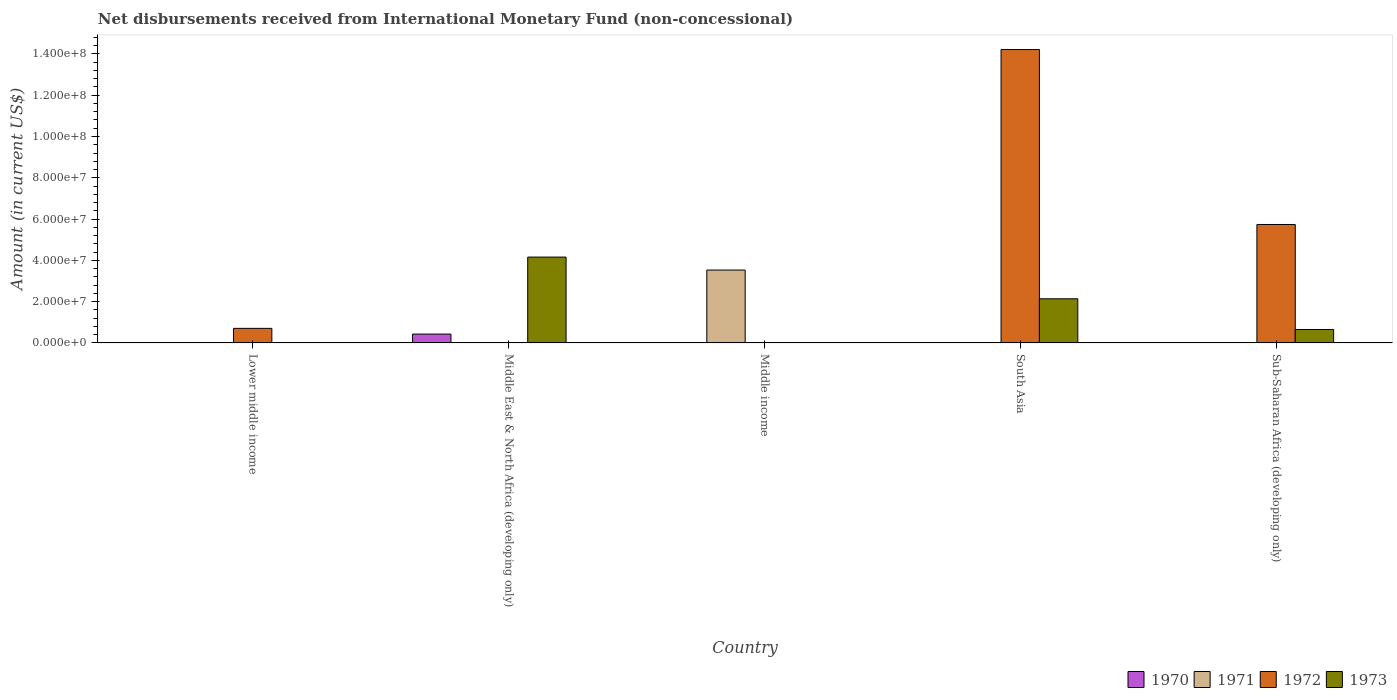How many different coloured bars are there?
Offer a terse response. 4. In how many cases, is the number of bars for a given country not equal to the number of legend labels?
Provide a short and direct response. 5. Across all countries, what is the maximum amount of disbursements received from International Monetary Fund in 1970?
Offer a very short reply. 4.30e+06. In which country was the amount of disbursements received from International Monetary Fund in 1970 maximum?
Offer a terse response. Middle East & North Africa (developing only). What is the total amount of disbursements received from International Monetary Fund in 1971 in the graph?
Give a very brief answer. 3.53e+07. What is the difference between the amount of disbursements received from International Monetary Fund in 1971 in Middle East & North Africa (developing only) and the amount of disbursements received from International Monetary Fund in 1973 in Lower middle income?
Your answer should be compact. 0. What is the average amount of disbursements received from International Monetary Fund in 1971 per country?
Your answer should be very brief. 7.06e+06. What is the difference between the amount of disbursements received from International Monetary Fund of/in 1973 and amount of disbursements received from International Monetary Fund of/in 1972 in Sub-Saharan Africa (developing only)?
Give a very brief answer. -5.09e+07. In how many countries, is the amount of disbursements received from International Monetary Fund in 1970 greater than 128000000 US$?
Offer a very short reply. 0. What is the difference between the highest and the second highest amount of disbursements received from International Monetary Fund in 1973?
Your answer should be compact. 3.51e+07. What is the difference between the highest and the lowest amount of disbursements received from International Monetary Fund in 1971?
Keep it short and to the point. 3.53e+07. In how many countries, is the amount of disbursements received from International Monetary Fund in 1973 greater than the average amount of disbursements received from International Monetary Fund in 1973 taken over all countries?
Keep it short and to the point. 2. How many countries are there in the graph?
Provide a short and direct response. 5. Are the values on the major ticks of Y-axis written in scientific E-notation?
Give a very brief answer. Yes. Does the graph contain any zero values?
Offer a very short reply. Yes. Does the graph contain grids?
Give a very brief answer. No. Where does the legend appear in the graph?
Keep it short and to the point. Bottom right. What is the title of the graph?
Keep it short and to the point. Net disbursements received from International Monetary Fund (non-concessional). What is the Amount (in current US$) in 1970 in Lower middle income?
Your answer should be very brief. 0. What is the Amount (in current US$) in 1971 in Lower middle income?
Your answer should be very brief. 0. What is the Amount (in current US$) of 1972 in Lower middle income?
Provide a succinct answer. 7.06e+06. What is the Amount (in current US$) in 1973 in Lower middle income?
Your response must be concise. 0. What is the Amount (in current US$) of 1970 in Middle East & North Africa (developing only)?
Your answer should be very brief. 4.30e+06. What is the Amount (in current US$) of 1973 in Middle East & North Africa (developing only)?
Make the answer very short. 4.16e+07. What is the Amount (in current US$) of 1971 in Middle income?
Give a very brief answer. 3.53e+07. What is the Amount (in current US$) of 1973 in Middle income?
Your answer should be compact. 0. What is the Amount (in current US$) in 1971 in South Asia?
Make the answer very short. 0. What is the Amount (in current US$) of 1972 in South Asia?
Keep it short and to the point. 1.42e+08. What is the Amount (in current US$) in 1973 in South Asia?
Your response must be concise. 2.14e+07. What is the Amount (in current US$) in 1970 in Sub-Saharan Africa (developing only)?
Offer a very short reply. 0. What is the Amount (in current US$) in 1971 in Sub-Saharan Africa (developing only)?
Ensure brevity in your answer.  0. What is the Amount (in current US$) in 1972 in Sub-Saharan Africa (developing only)?
Make the answer very short. 5.74e+07. What is the Amount (in current US$) of 1973 in Sub-Saharan Africa (developing only)?
Provide a succinct answer. 6.51e+06. Across all countries, what is the maximum Amount (in current US$) of 1970?
Make the answer very short. 4.30e+06. Across all countries, what is the maximum Amount (in current US$) of 1971?
Provide a succinct answer. 3.53e+07. Across all countries, what is the maximum Amount (in current US$) of 1972?
Offer a very short reply. 1.42e+08. Across all countries, what is the maximum Amount (in current US$) of 1973?
Provide a succinct answer. 4.16e+07. Across all countries, what is the minimum Amount (in current US$) in 1971?
Make the answer very short. 0. Across all countries, what is the minimum Amount (in current US$) of 1972?
Provide a succinct answer. 0. Across all countries, what is the minimum Amount (in current US$) of 1973?
Your response must be concise. 0. What is the total Amount (in current US$) of 1970 in the graph?
Ensure brevity in your answer.  4.30e+06. What is the total Amount (in current US$) of 1971 in the graph?
Provide a succinct answer. 3.53e+07. What is the total Amount (in current US$) of 1972 in the graph?
Your response must be concise. 2.07e+08. What is the total Amount (in current US$) in 1973 in the graph?
Ensure brevity in your answer.  6.95e+07. What is the difference between the Amount (in current US$) in 1972 in Lower middle income and that in South Asia?
Offer a very short reply. -1.35e+08. What is the difference between the Amount (in current US$) of 1972 in Lower middle income and that in Sub-Saharan Africa (developing only)?
Provide a succinct answer. -5.03e+07. What is the difference between the Amount (in current US$) of 1973 in Middle East & North Africa (developing only) and that in South Asia?
Offer a terse response. 2.02e+07. What is the difference between the Amount (in current US$) in 1973 in Middle East & North Africa (developing only) and that in Sub-Saharan Africa (developing only)?
Give a very brief answer. 3.51e+07. What is the difference between the Amount (in current US$) of 1972 in South Asia and that in Sub-Saharan Africa (developing only)?
Ensure brevity in your answer.  8.48e+07. What is the difference between the Amount (in current US$) of 1973 in South Asia and that in Sub-Saharan Africa (developing only)?
Make the answer very short. 1.49e+07. What is the difference between the Amount (in current US$) in 1972 in Lower middle income and the Amount (in current US$) in 1973 in Middle East & North Africa (developing only)?
Give a very brief answer. -3.45e+07. What is the difference between the Amount (in current US$) of 1972 in Lower middle income and the Amount (in current US$) of 1973 in South Asia?
Provide a succinct answer. -1.43e+07. What is the difference between the Amount (in current US$) of 1972 in Lower middle income and the Amount (in current US$) of 1973 in Sub-Saharan Africa (developing only)?
Keep it short and to the point. 5.46e+05. What is the difference between the Amount (in current US$) in 1970 in Middle East & North Africa (developing only) and the Amount (in current US$) in 1971 in Middle income?
Make the answer very short. -3.10e+07. What is the difference between the Amount (in current US$) of 1970 in Middle East & North Africa (developing only) and the Amount (in current US$) of 1972 in South Asia?
Keep it short and to the point. -1.38e+08. What is the difference between the Amount (in current US$) of 1970 in Middle East & North Africa (developing only) and the Amount (in current US$) of 1973 in South Asia?
Make the answer very short. -1.71e+07. What is the difference between the Amount (in current US$) of 1970 in Middle East & North Africa (developing only) and the Amount (in current US$) of 1972 in Sub-Saharan Africa (developing only)?
Ensure brevity in your answer.  -5.31e+07. What is the difference between the Amount (in current US$) of 1970 in Middle East & North Africa (developing only) and the Amount (in current US$) of 1973 in Sub-Saharan Africa (developing only)?
Provide a succinct answer. -2.21e+06. What is the difference between the Amount (in current US$) in 1971 in Middle income and the Amount (in current US$) in 1972 in South Asia?
Offer a terse response. -1.07e+08. What is the difference between the Amount (in current US$) in 1971 in Middle income and the Amount (in current US$) in 1973 in South Asia?
Your answer should be compact. 1.39e+07. What is the difference between the Amount (in current US$) in 1971 in Middle income and the Amount (in current US$) in 1972 in Sub-Saharan Africa (developing only)?
Your answer should be compact. -2.21e+07. What is the difference between the Amount (in current US$) of 1971 in Middle income and the Amount (in current US$) of 1973 in Sub-Saharan Africa (developing only)?
Keep it short and to the point. 2.88e+07. What is the difference between the Amount (in current US$) of 1972 in South Asia and the Amount (in current US$) of 1973 in Sub-Saharan Africa (developing only)?
Provide a succinct answer. 1.36e+08. What is the average Amount (in current US$) in 1970 per country?
Provide a succinct answer. 8.60e+05. What is the average Amount (in current US$) of 1971 per country?
Your answer should be very brief. 7.06e+06. What is the average Amount (in current US$) in 1972 per country?
Keep it short and to the point. 4.13e+07. What is the average Amount (in current US$) of 1973 per country?
Ensure brevity in your answer.  1.39e+07. What is the difference between the Amount (in current US$) of 1970 and Amount (in current US$) of 1973 in Middle East & North Africa (developing only)?
Provide a succinct answer. -3.73e+07. What is the difference between the Amount (in current US$) in 1972 and Amount (in current US$) in 1973 in South Asia?
Your answer should be very brief. 1.21e+08. What is the difference between the Amount (in current US$) of 1972 and Amount (in current US$) of 1973 in Sub-Saharan Africa (developing only)?
Give a very brief answer. 5.09e+07. What is the ratio of the Amount (in current US$) of 1972 in Lower middle income to that in South Asia?
Provide a short and direct response. 0.05. What is the ratio of the Amount (in current US$) in 1972 in Lower middle income to that in Sub-Saharan Africa (developing only)?
Give a very brief answer. 0.12. What is the ratio of the Amount (in current US$) in 1973 in Middle East & North Africa (developing only) to that in South Asia?
Provide a succinct answer. 1.94. What is the ratio of the Amount (in current US$) in 1973 in Middle East & North Africa (developing only) to that in Sub-Saharan Africa (developing only)?
Make the answer very short. 6.39. What is the ratio of the Amount (in current US$) in 1972 in South Asia to that in Sub-Saharan Africa (developing only)?
Your answer should be very brief. 2.48. What is the ratio of the Amount (in current US$) in 1973 in South Asia to that in Sub-Saharan Africa (developing only)?
Your response must be concise. 3.29. What is the difference between the highest and the second highest Amount (in current US$) of 1972?
Offer a terse response. 8.48e+07. What is the difference between the highest and the second highest Amount (in current US$) of 1973?
Your answer should be compact. 2.02e+07. What is the difference between the highest and the lowest Amount (in current US$) in 1970?
Your answer should be compact. 4.30e+06. What is the difference between the highest and the lowest Amount (in current US$) of 1971?
Offer a terse response. 3.53e+07. What is the difference between the highest and the lowest Amount (in current US$) in 1972?
Offer a terse response. 1.42e+08. What is the difference between the highest and the lowest Amount (in current US$) in 1973?
Your answer should be compact. 4.16e+07. 